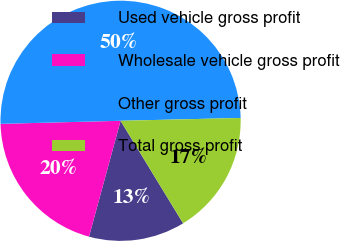<chart> <loc_0><loc_0><loc_500><loc_500><pie_chart><fcel>Used vehicle gross profit<fcel>Wholesale vehicle gross profit<fcel>Other gross profit<fcel>Total gross profit<nl><fcel>12.95%<fcel>20.36%<fcel>50.03%<fcel>16.66%<nl></chart> 